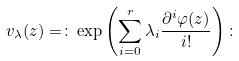Convert formula to latex. <formula><loc_0><loc_0><loc_500><loc_500>v _ { \lambda } ( z ) = \colon \exp \left ( \sum _ { i = 0 } ^ { r } \lambda _ { i } \frac { \partial ^ { i } \varphi ( z ) } { i ! } \right ) \colon</formula> 